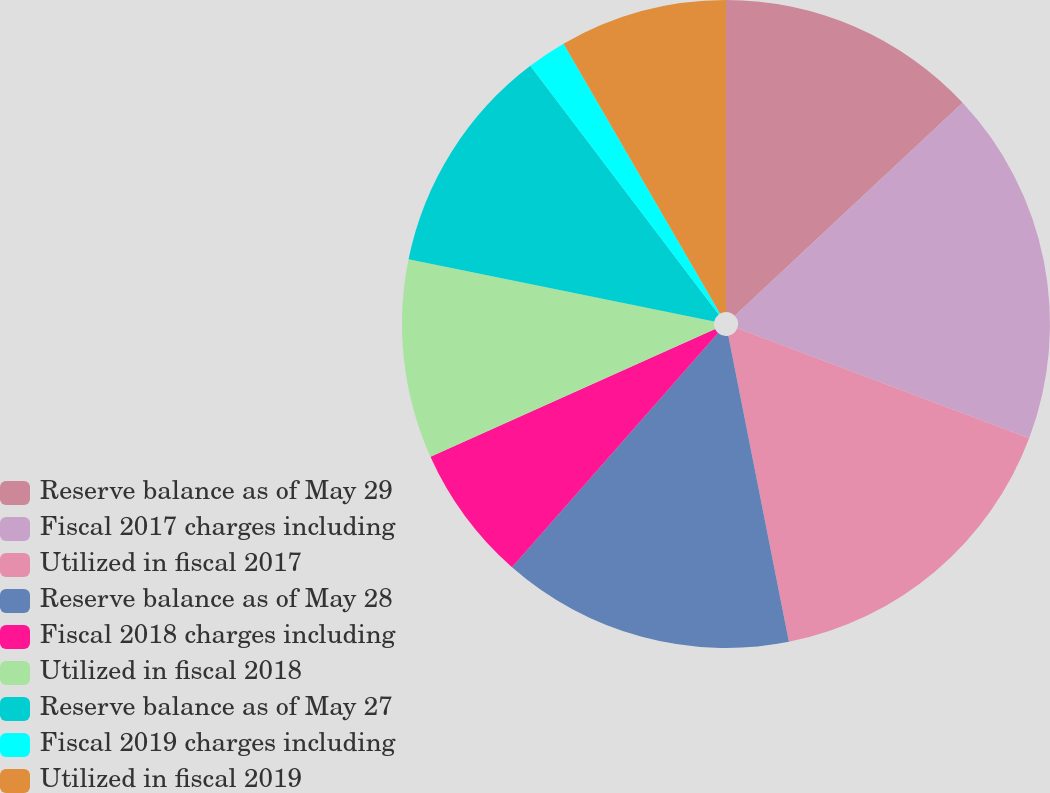Convert chart to OTSL. <chart><loc_0><loc_0><loc_500><loc_500><pie_chart><fcel>Reserve balance as of May 29<fcel>Fiscal 2017 charges including<fcel>Utilized in fiscal 2017<fcel>Reserve balance as of May 28<fcel>Fiscal 2018 charges including<fcel>Utilized in fiscal 2018<fcel>Reserve balance as of May 27<fcel>Fiscal 2019 charges including<fcel>Utilized in fiscal 2019<nl><fcel>13.03%<fcel>17.71%<fcel>16.15%<fcel>14.59%<fcel>6.8%<fcel>9.92%<fcel>11.48%<fcel>1.96%<fcel>8.36%<nl></chart> 